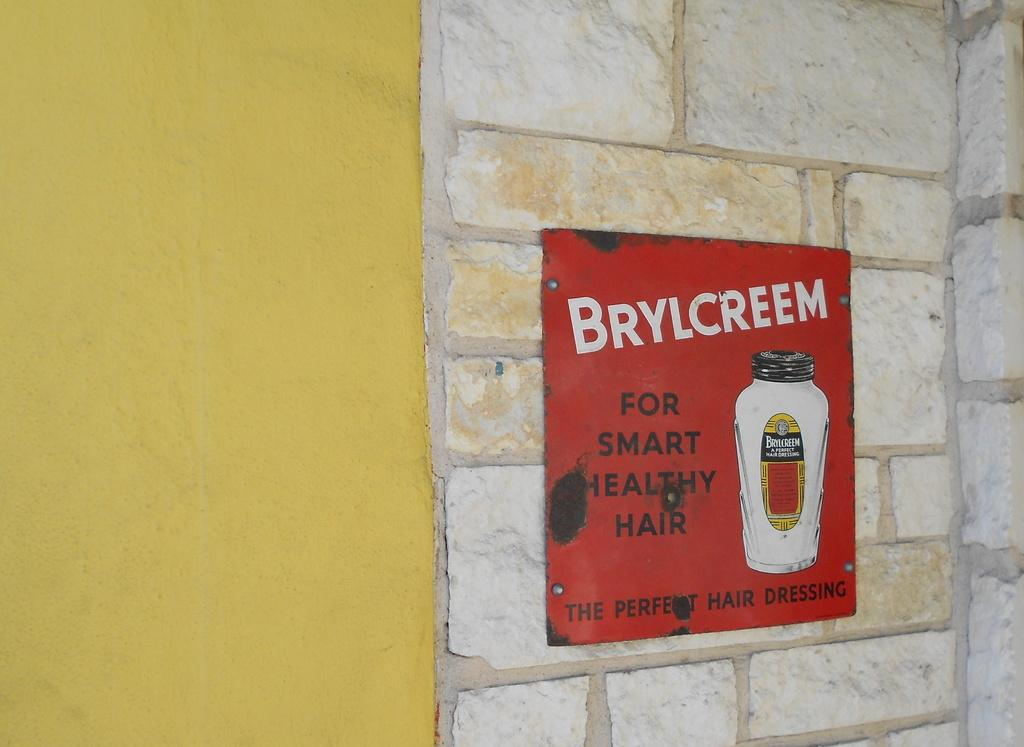<image>
Present a compact description of the photo's key features. Red sign for Brylcreem next to a yellow door. 